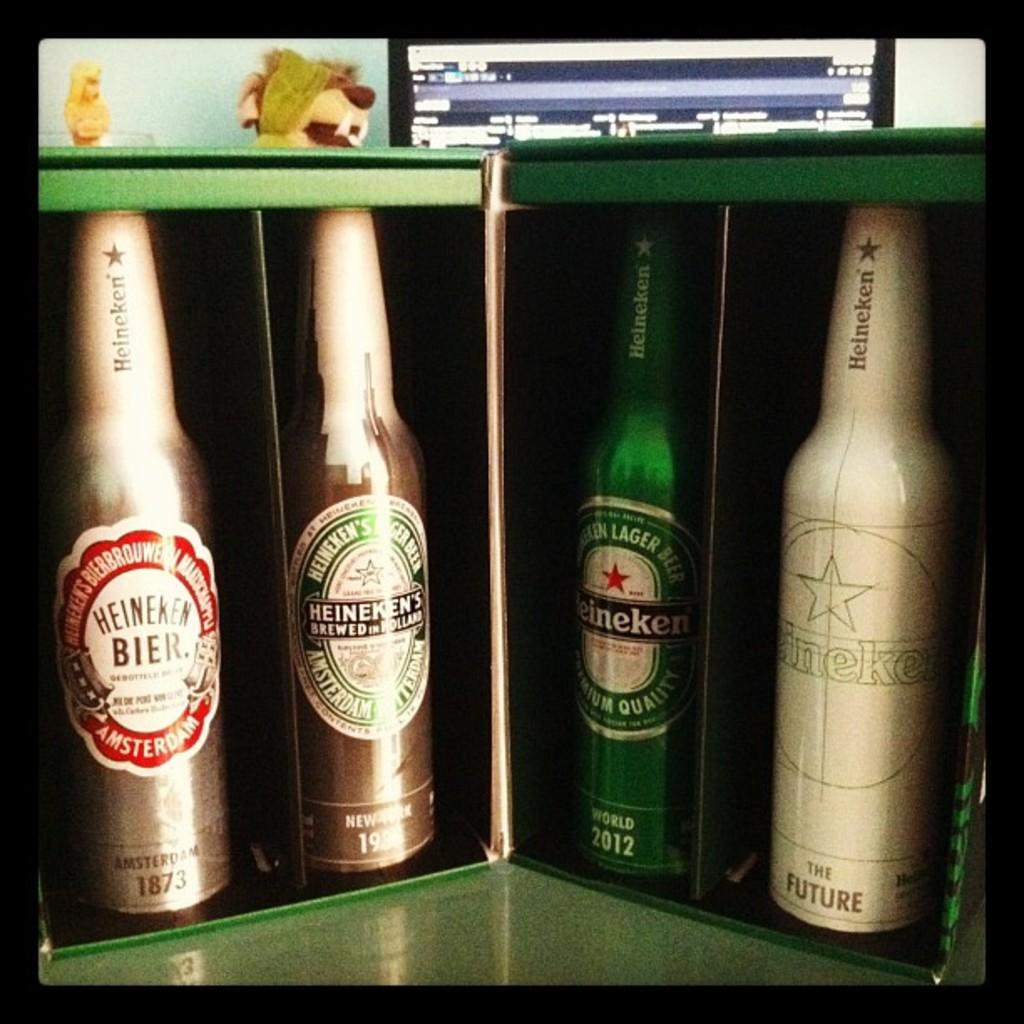What is date on the beer bottle to the left?
Offer a terse response. 1873. 